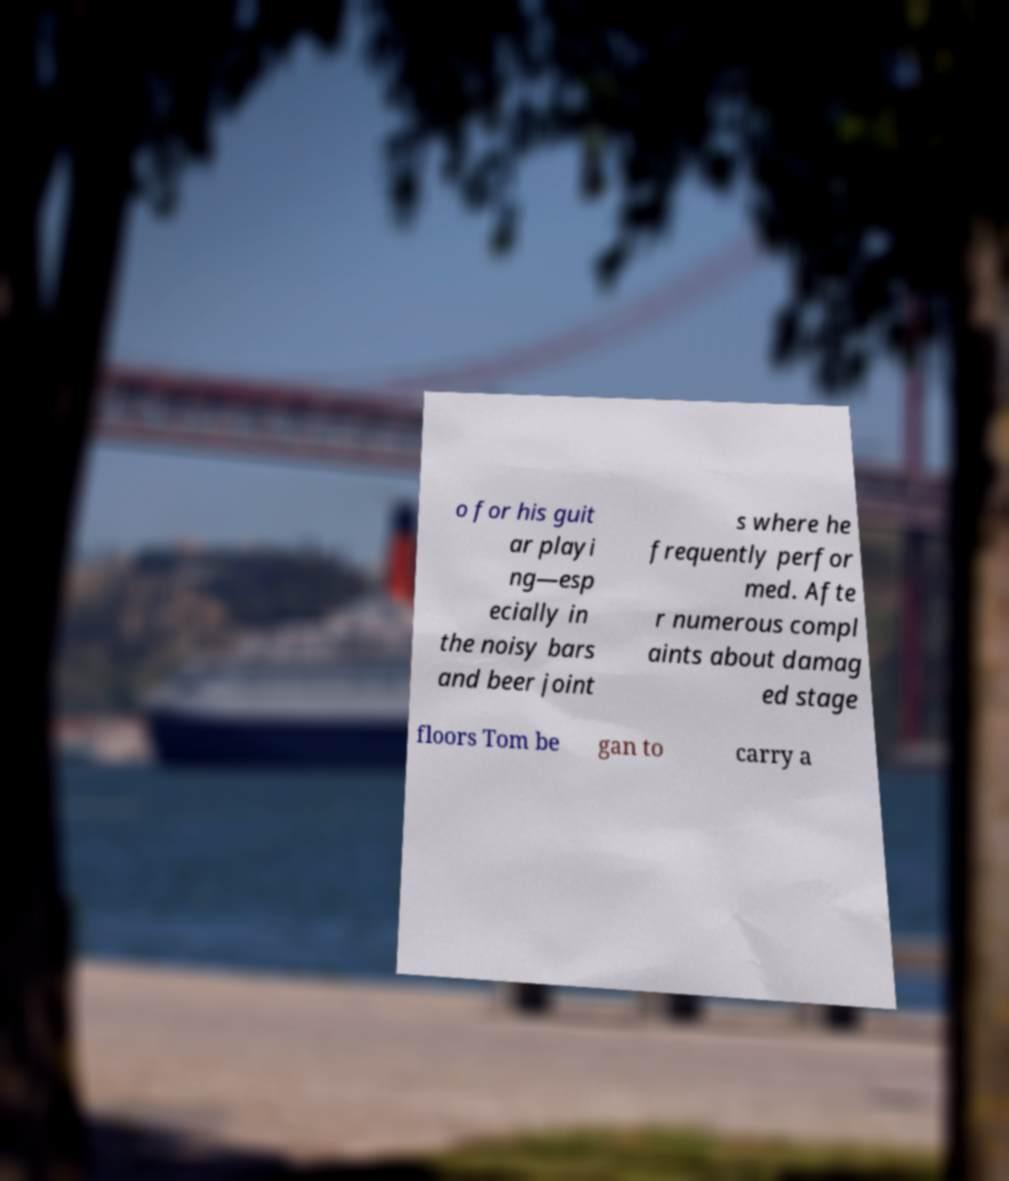For documentation purposes, I need the text within this image transcribed. Could you provide that? o for his guit ar playi ng—esp ecially in the noisy bars and beer joint s where he frequently perfor med. Afte r numerous compl aints about damag ed stage floors Tom be gan to carry a 